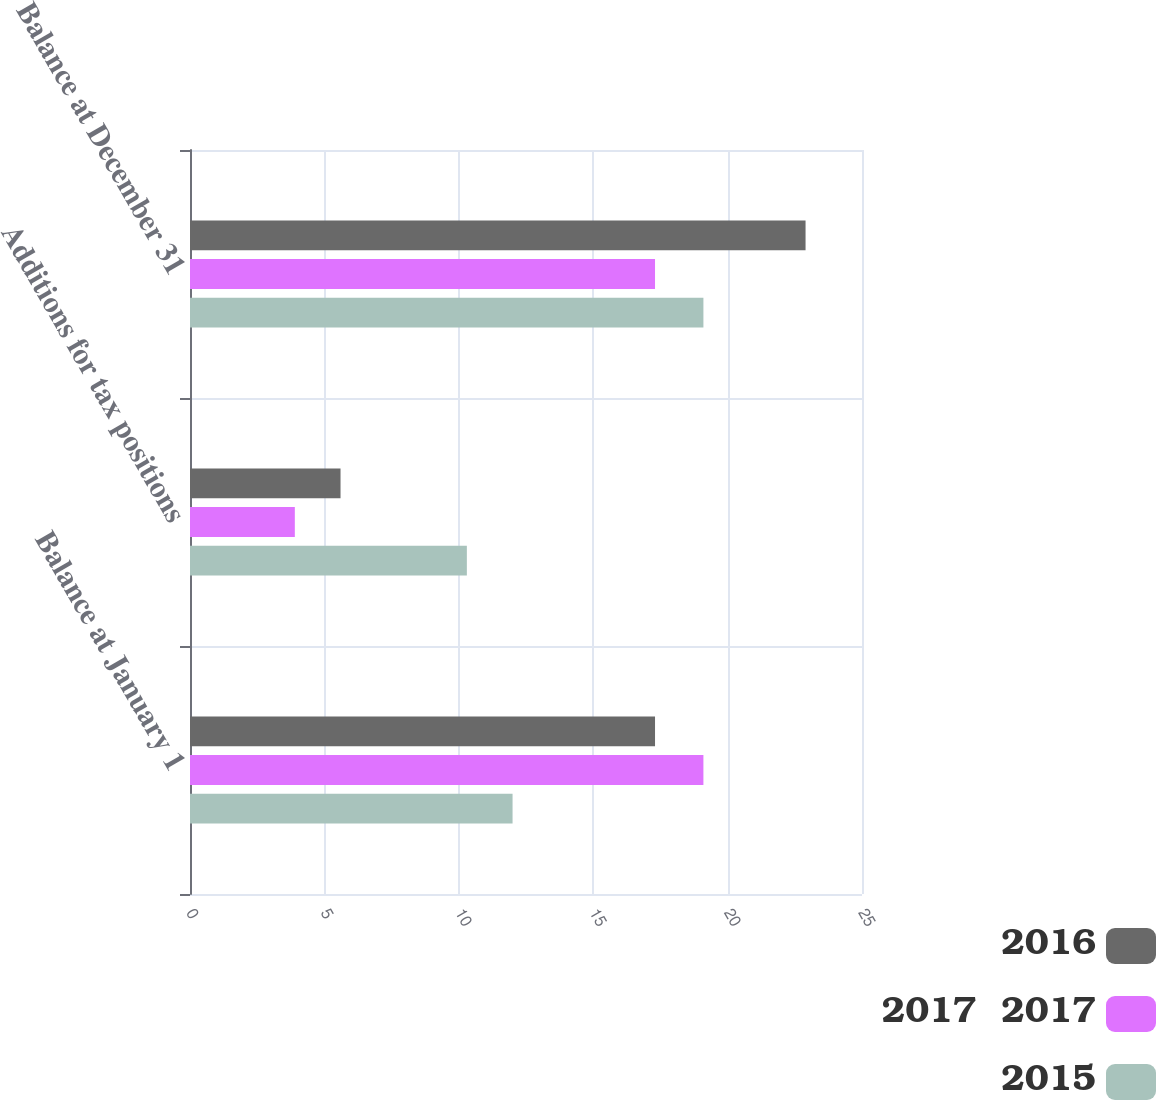Convert chart. <chart><loc_0><loc_0><loc_500><loc_500><stacked_bar_chart><ecel><fcel>Balance at January 1<fcel>Additions for tax positions<fcel>Balance at December 31<nl><fcel>2016<fcel>17.3<fcel>5.6<fcel>22.9<nl><fcel>2017  2017<fcel>19.1<fcel>3.9<fcel>17.3<nl><fcel>2015<fcel>12<fcel>10.3<fcel>19.1<nl></chart> 